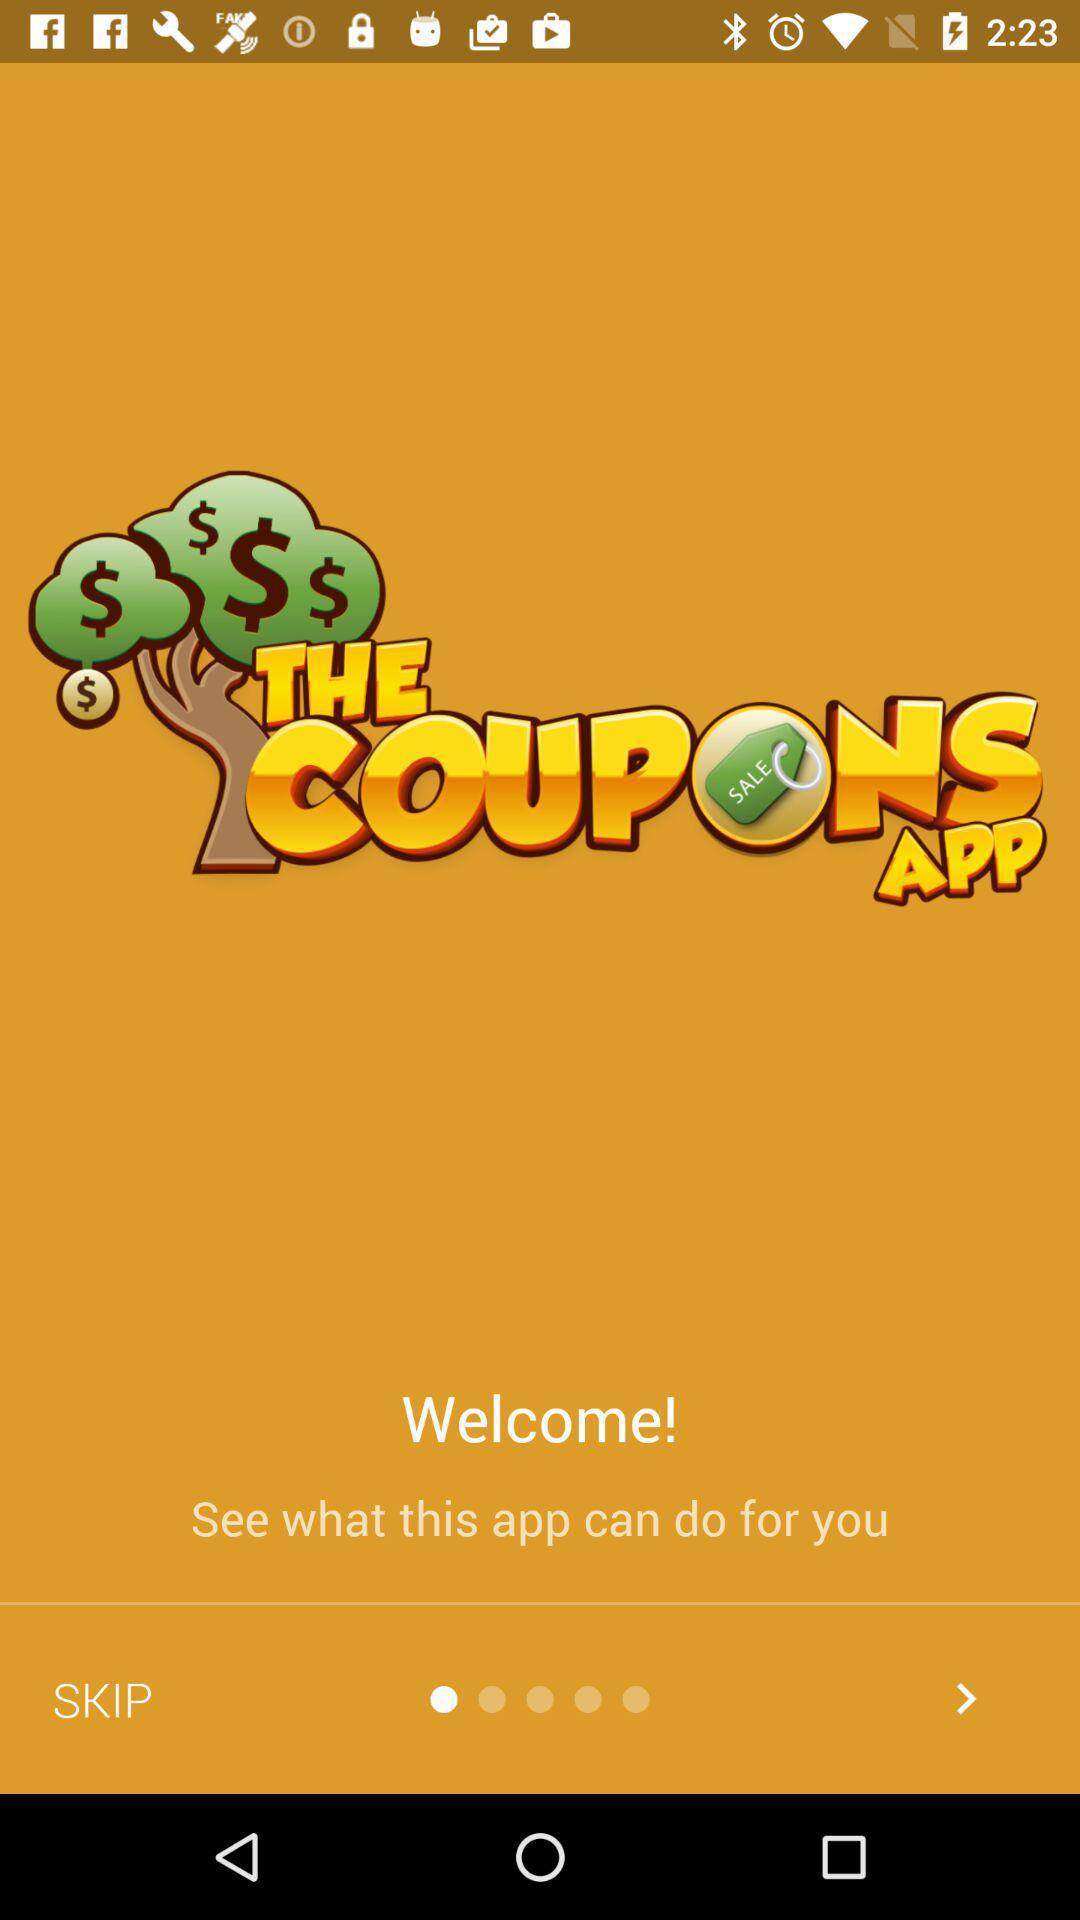What is the name of the application? The name of the application is "THE COUPONS APP". 